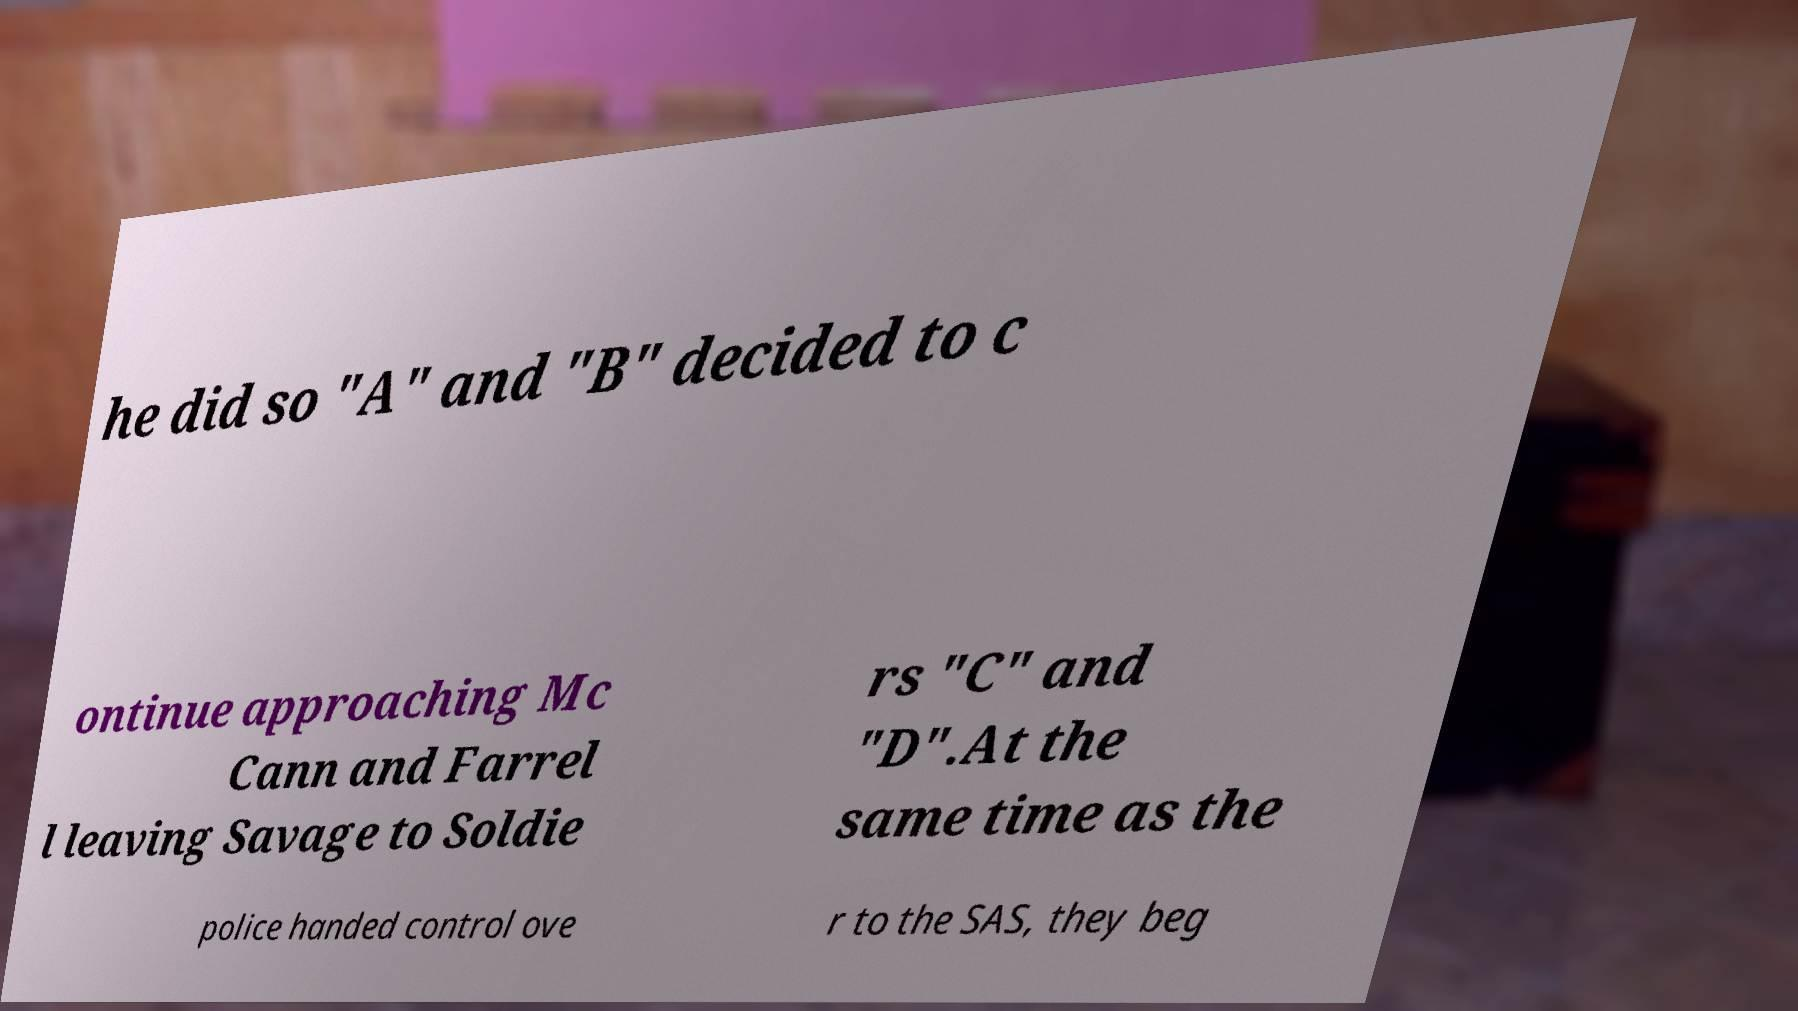Could you extract and type out the text from this image? he did so "A" and "B" decided to c ontinue approaching Mc Cann and Farrel l leaving Savage to Soldie rs "C" and "D".At the same time as the police handed control ove r to the SAS, they beg 